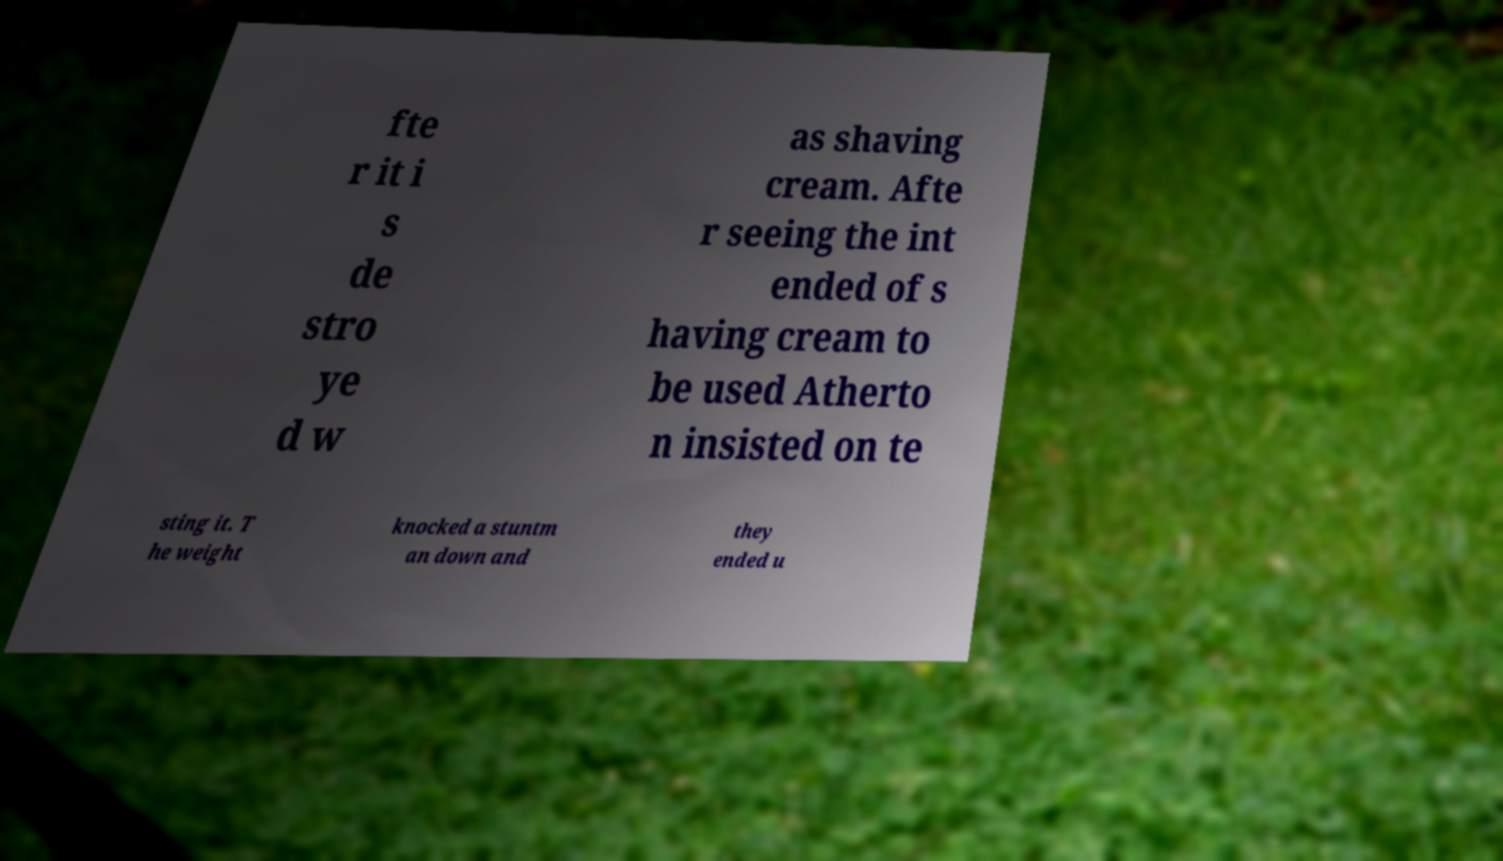Please identify and transcribe the text found in this image. fte r it i s de stro ye d w as shaving cream. Afte r seeing the int ended of s having cream to be used Atherto n insisted on te sting it. T he weight knocked a stuntm an down and they ended u 